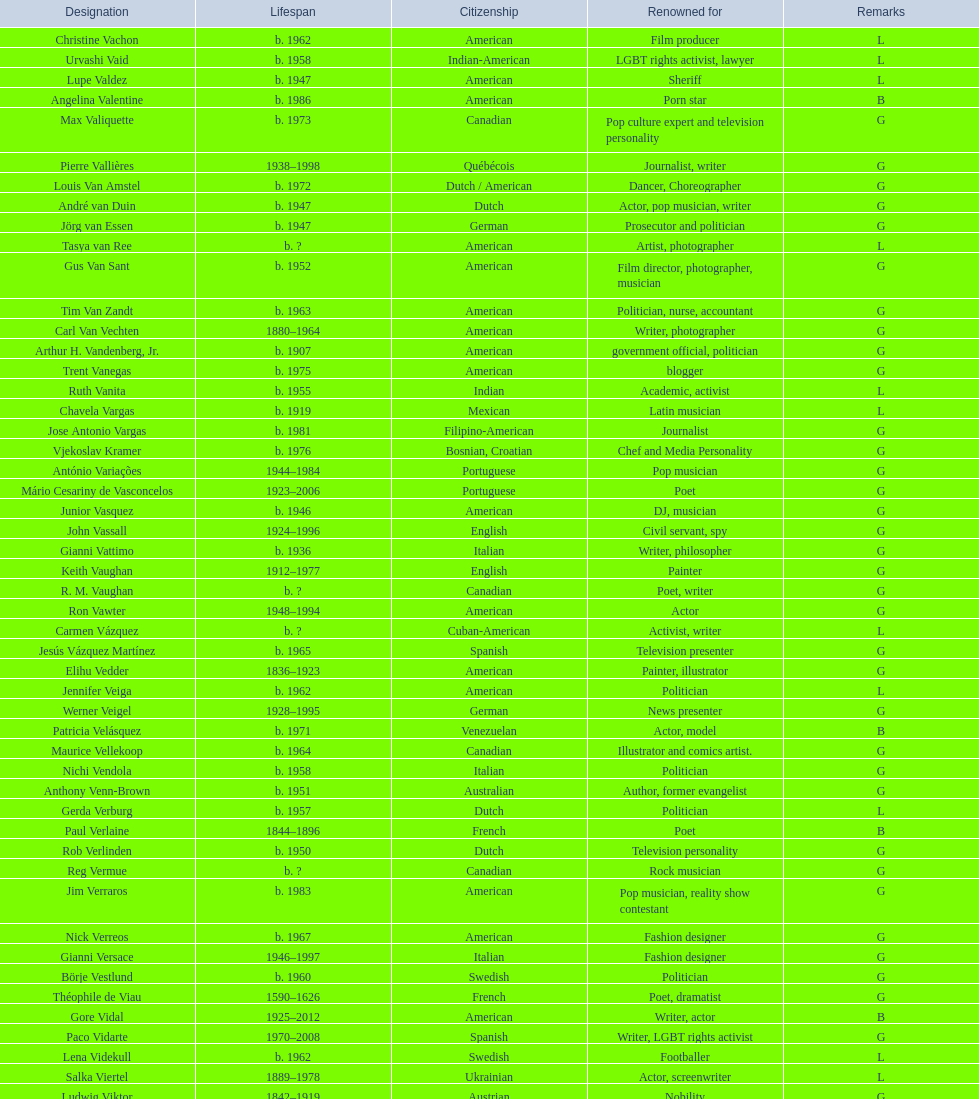Patricia velasquez and ron vawter both had what career? Actor. 